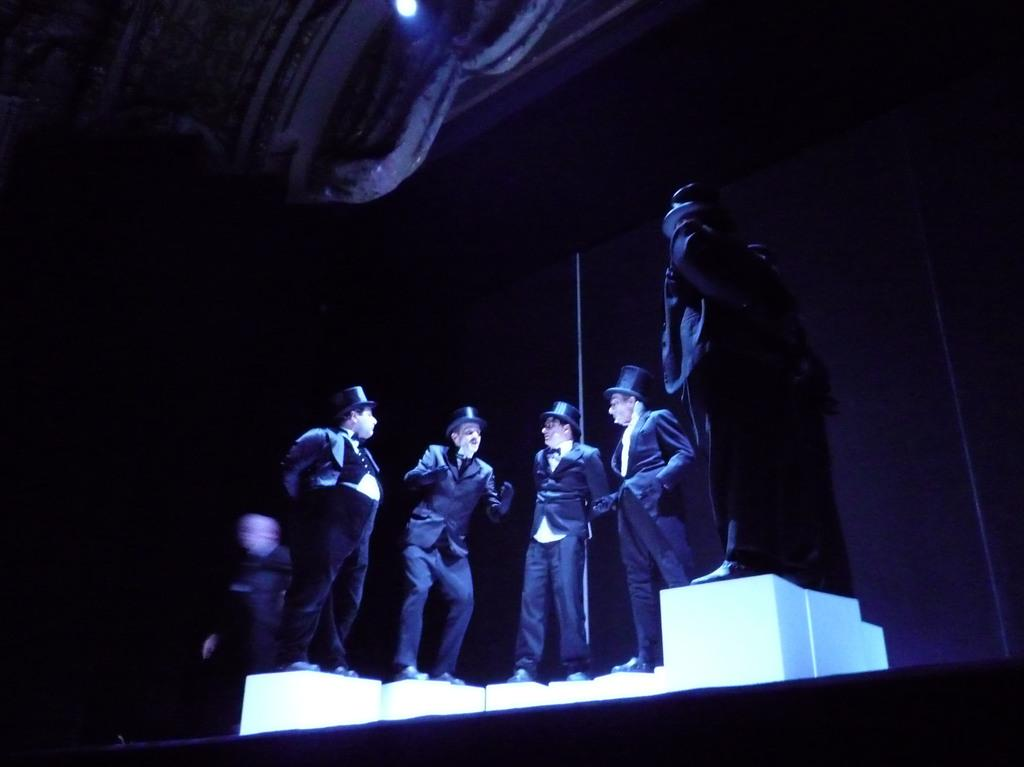How many people are in the image? There are four persons standing in the image. What are the persons wearing on their upper bodies? The persons are wearing suits. What accessories are the persons wearing on their hands? The persons are wearing gloves. What type of footwear are the persons wearing? The persons are wearing shoes. What headgear are the persons wearing? The persons are wearing caps. What can be seen on the right side of the image? There is a statue on the right side of the image. What is visible at the top of the image? There is a light at the top of the image. What type of chin can be seen on the statue in the image? There is no chin visible on the statue in the image, as it is not a living being with a chin. Do the persons in the image have tails? No, the persons in the image do not have tails, as they are human beings and do not possess tails. 